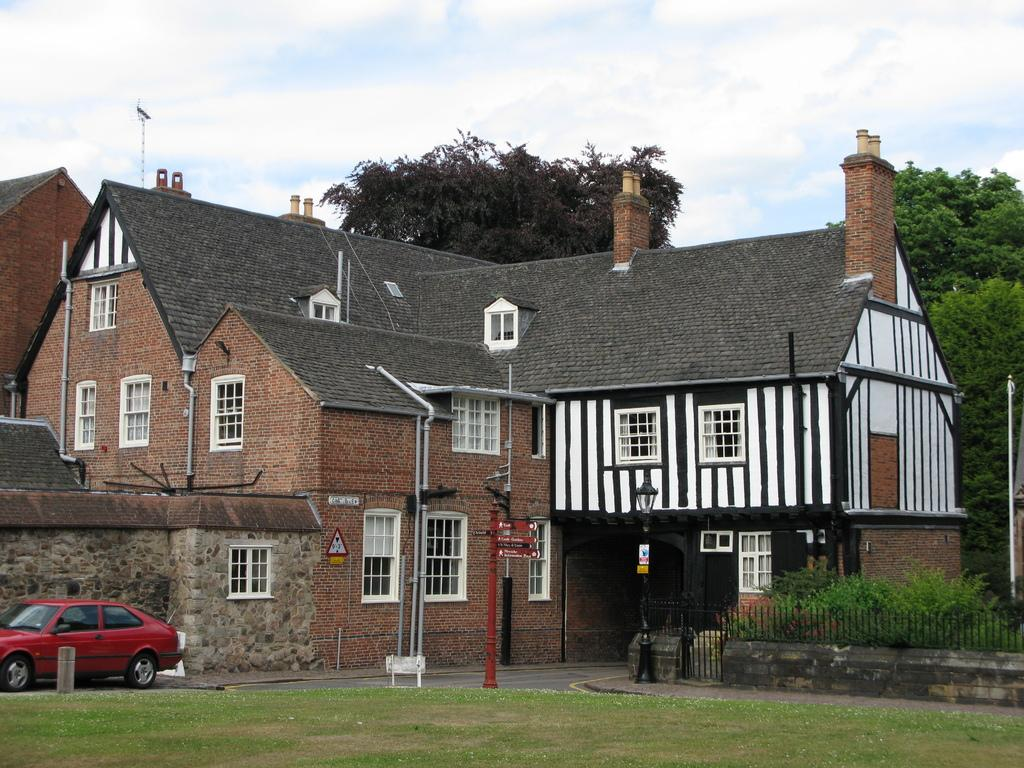What type of vehicle is located in the bottom left corner of the image? There is a car in the bottom left corner of the image. What structure is in the middle of the image? There is a house in the middle of the image. What can be seen in the background of the image? The sky is visible in the background of the image. What type of cap is being worn by the house in the image? There is no cap present in the image, as the main subject is a house. 